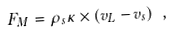Convert formula to latex. <formula><loc_0><loc_0><loc_500><loc_500>F _ { M } = \rho _ { s } \kappa \times ( v _ { L } - v _ { s } ) \ ,</formula> 